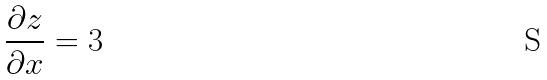<formula> <loc_0><loc_0><loc_500><loc_500>\frac { \partial z } { \partial x } = 3</formula> 